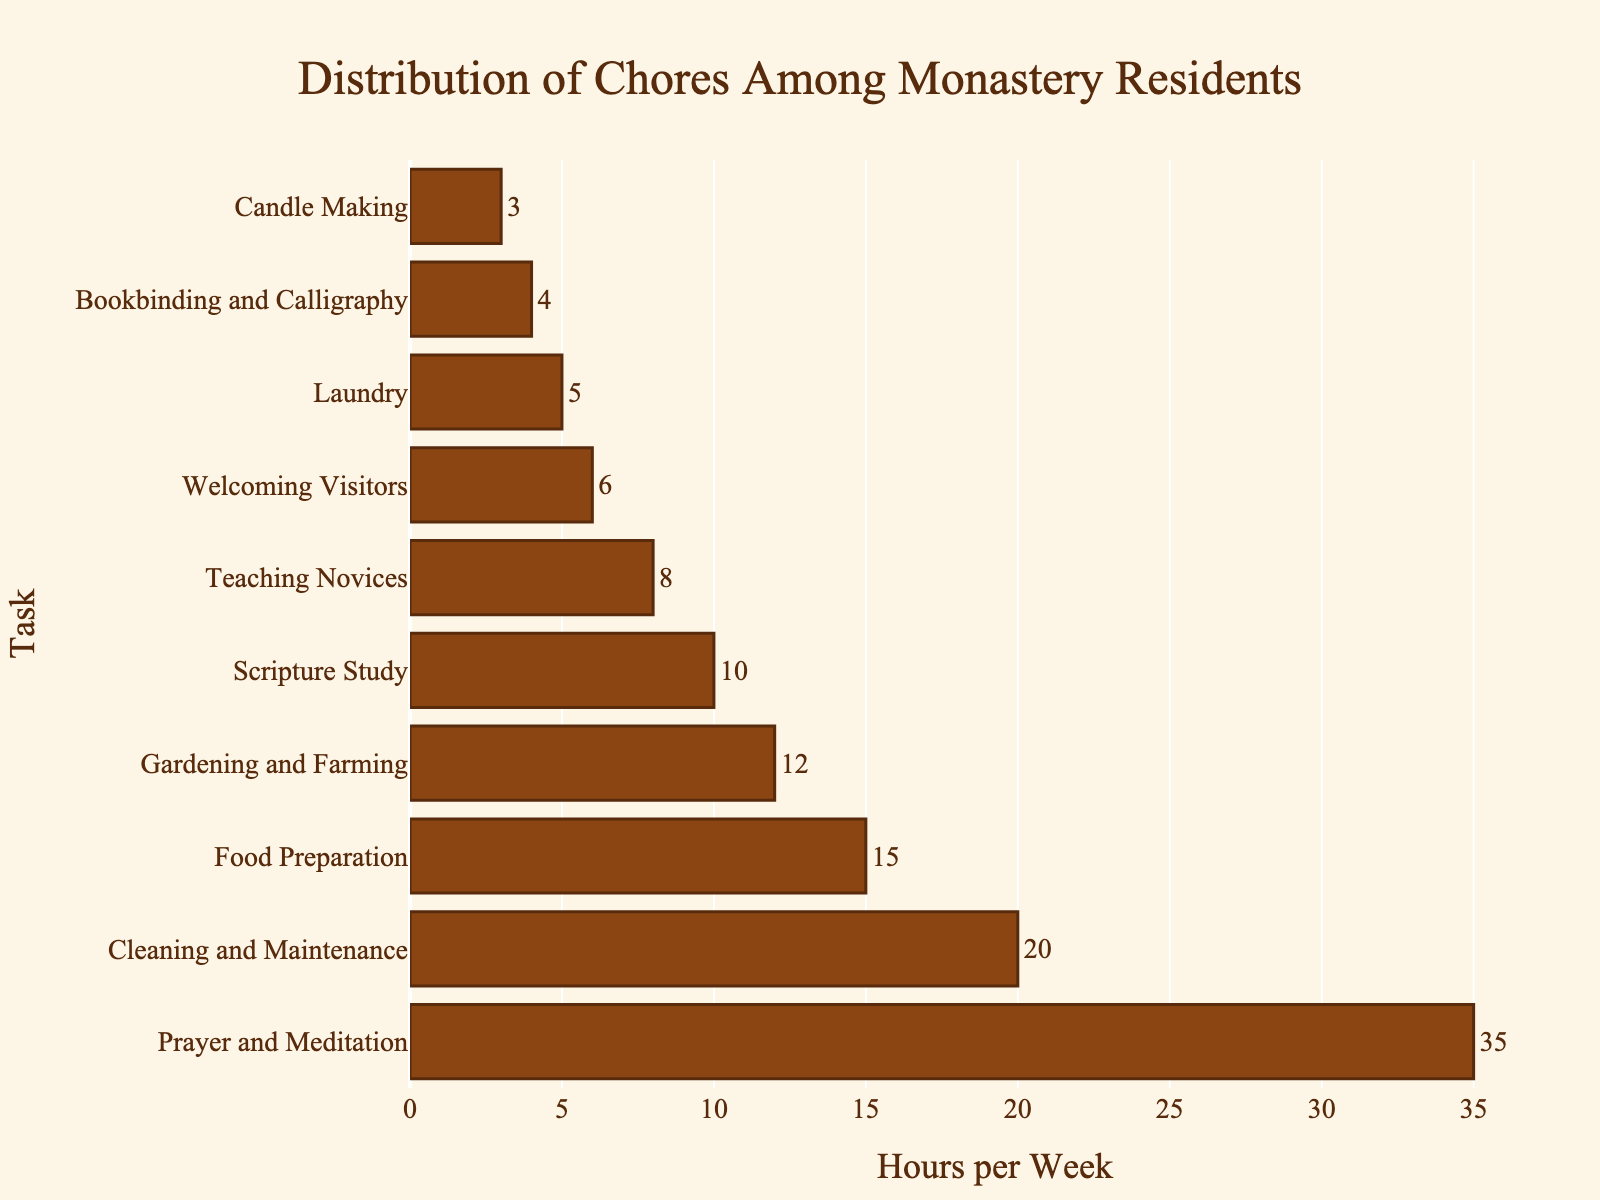Which task requires the most hours per week? The task that requires the most hours per week can be identified by looking for the longest bar in the chart. The longest bar represents "Prayer and Meditation" at 35 hours per week.
Answer: Prayer and Meditation How many hours are spent on Food Preparation and Gardening and Farming combined? To find the combined hours for "Food Preparation" and "Gardening and Farming," add their respective hours from the chart: 15 (Food Preparation) + 12 (Gardening and Farming) = 27 hours.
Answer: 27 hours Which task is undertaken fewer hours per week: Laundry or Candle Making? Compare the lengths of the bars for "Laundry" and "Candle Making." The bar for "Candle Making" (3 hours) is shorter than that for "Laundry" (5 hours).
Answer: Candle Making What is the average number of hours spent on Cleaning and Maintenance, Scripture Study, and Welcoming Visitors? First, find the sum of hours for the three tasks: 20 (Cleaning and Maintenance) + 10 (Scripture Study) + 6 (Welcoming Visitors) = 36 hours. Then, divide by the number of tasks: 36 / 3 = 12 hours.
Answer: 12 hours Which three tasks are the least time-consuming, and what are their combined hours per week? Identify the three shortest bars: "Candle Making" (3 hours), "Bookbinding and Calligraphy" (4 hours), and "Laundry" (5 hours). Add their hours: 3 + 4 + 5 = 12 hours.
Answer: Candle Making, Bookbinding and Calligraphy, Laundry; 12 hours How many more hours per week are spent on Prayer and Meditation compared to Teaching Novices? Subtract the hours spent on "Teaching Novices" (8 hours) from "Prayer and Meditation" (35 hours): 35 - 8 = 27 hours.
Answer: 27 hours Which task is allocated more hours: Gardening and Farming or Scripture Study? Compare the lengths of the bars for "Gardening and Farming" and "Scripture Study." "Gardening and Farming" (12 hours) is allocated more hours than "Scripture Study" (10 hours).
Answer: Gardening and Farming What is the total number of hours spent on all tasks? Sum the hours for all tasks: 35 (Prayer and Meditation) + 20 (Cleaning and Maintenance) + 15 (Food Preparation) + 12 (Gardening and Farming) + 10 (Scripture Study) + 8 (Teaching Novices) + 6 (Welcoming Visitors) + 5 (Laundry) + 4 (Bookbinding and Calligraphy) + 3 (Candle Making) = 118 hours.
Answer: 118 hours Are more hours dedicated to Teaching Novices or Welcoming Visitors? Compare the lengths of the bars for "Teaching Novices" and "Welcoming Visitors." "Teaching Novices" (8 hours) has a longer bar than "Welcoming Visitors" (6 hours).
Answer: Teaching Novices How do the hours spent on Cleaning and Maintenance compare to those spent on Food Preparation and Candle Making combined? First, sum the hours for "Food Preparation" and "Candle Making": 15 (Food Preparation) + 3 (Candle Making) = 18 hours. Then compare with "Cleaning and Maintenance": 20 hours. "Cleaning and Maintenance" has 2 more hours (20 - 18).
Answer: Cleaning and Maintenance has 2 more hours 